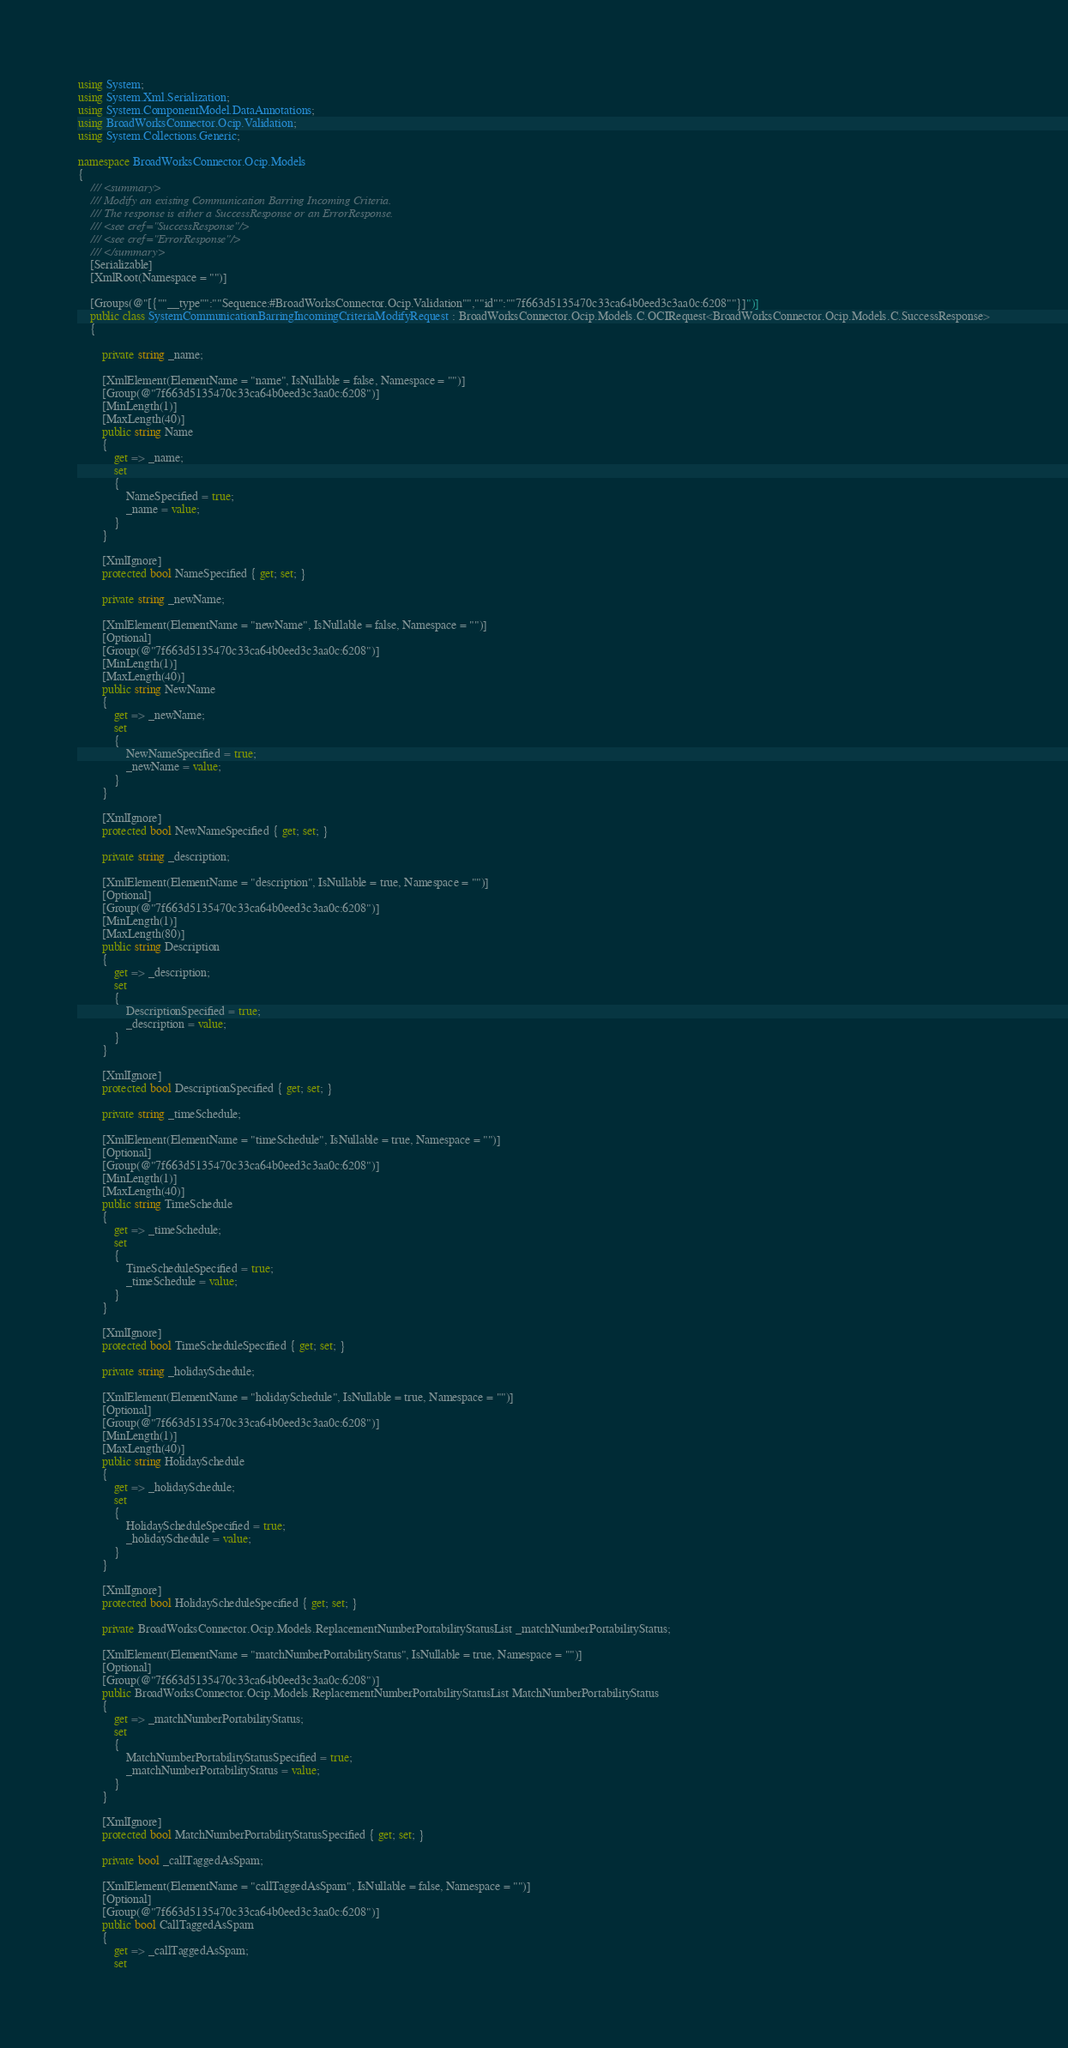Convert code to text. <code><loc_0><loc_0><loc_500><loc_500><_C#_>using System;
using System.Xml.Serialization;
using System.ComponentModel.DataAnnotations;
using BroadWorksConnector.Ocip.Validation;
using System.Collections.Generic;

namespace BroadWorksConnector.Ocip.Models
{
    /// <summary>
    /// Modify an existing Communication Barring Incoming Criteria.
    /// The response is either a SuccessResponse or an ErrorResponse.
    /// <see cref="SuccessResponse"/>
    /// <see cref="ErrorResponse"/>
    /// </summary>
    [Serializable]
    [XmlRoot(Namespace = "")]

    [Groups(@"[{""__type"":""Sequence:#BroadWorksConnector.Ocip.Validation"",""id"":""7f663d5135470c33ca64b0eed3c3aa0c:6208""}]")]
    public class SystemCommunicationBarringIncomingCriteriaModifyRequest : BroadWorksConnector.Ocip.Models.C.OCIRequest<BroadWorksConnector.Ocip.Models.C.SuccessResponse>
    {

        private string _name;

        [XmlElement(ElementName = "name", IsNullable = false, Namespace = "")]
        [Group(@"7f663d5135470c33ca64b0eed3c3aa0c:6208")]
        [MinLength(1)]
        [MaxLength(40)]
        public string Name
        {
            get => _name;
            set
            {
                NameSpecified = true;
                _name = value;
            }
        }

        [XmlIgnore]
        protected bool NameSpecified { get; set; }

        private string _newName;

        [XmlElement(ElementName = "newName", IsNullable = false, Namespace = "")]
        [Optional]
        [Group(@"7f663d5135470c33ca64b0eed3c3aa0c:6208")]
        [MinLength(1)]
        [MaxLength(40)]
        public string NewName
        {
            get => _newName;
            set
            {
                NewNameSpecified = true;
                _newName = value;
            }
        }

        [XmlIgnore]
        protected bool NewNameSpecified { get; set; }

        private string _description;

        [XmlElement(ElementName = "description", IsNullable = true, Namespace = "")]
        [Optional]
        [Group(@"7f663d5135470c33ca64b0eed3c3aa0c:6208")]
        [MinLength(1)]
        [MaxLength(80)]
        public string Description
        {
            get => _description;
            set
            {
                DescriptionSpecified = true;
                _description = value;
            }
        }

        [XmlIgnore]
        protected bool DescriptionSpecified { get; set; }

        private string _timeSchedule;

        [XmlElement(ElementName = "timeSchedule", IsNullable = true, Namespace = "")]
        [Optional]
        [Group(@"7f663d5135470c33ca64b0eed3c3aa0c:6208")]
        [MinLength(1)]
        [MaxLength(40)]
        public string TimeSchedule
        {
            get => _timeSchedule;
            set
            {
                TimeScheduleSpecified = true;
                _timeSchedule = value;
            }
        }

        [XmlIgnore]
        protected bool TimeScheduleSpecified { get; set; }

        private string _holidaySchedule;

        [XmlElement(ElementName = "holidaySchedule", IsNullable = true, Namespace = "")]
        [Optional]
        [Group(@"7f663d5135470c33ca64b0eed3c3aa0c:6208")]
        [MinLength(1)]
        [MaxLength(40)]
        public string HolidaySchedule
        {
            get => _holidaySchedule;
            set
            {
                HolidayScheduleSpecified = true;
                _holidaySchedule = value;
            }
        }

        [XmlIgnore]
        protected bool HolidayScheduleSpecified { get; set; }

        private BroadWorksConnector.Ocip.Models.ReplacementNumberPortabilityStatusList _matchNumberPortabilityStatus;

        [XmlElement(ElementName = "matchNumberPortabilityStatus", IsNullable = true, Namespace = "")]
        [Optional]
        [Group(@"7f663d5135470c33ca64b0eed3c3aa0c:6208")]
        public BroadWorksConnector.Ocip.Models.ReplacementNumberPortabilityStatusList MatchNumberPortabilityStatus
        {
            get => _matchNumberPortabilityStatus;
            set
            {
                MatchNumberPortabilityStatusSpecified = true;
                _matchNumberPortabilityStatus = value;
            }
        }

        [XmlIgnore]
        protected bool MatchNumberPortabilityStatusSpecified { get; set; }

        private bool _callTaggedAsSpam;

        [XmlElement(ElementName = "callTaggedAsSpam", IsNullable = false, Namespace = "")]
        [Optional]
        [Group(@"7f663d5135470c33ca64b0eed3c3aa0c:6208")]
        public bool CallTaggedAsSpam
        {
            get => _callTaggedAsSpam;
            set</code> 